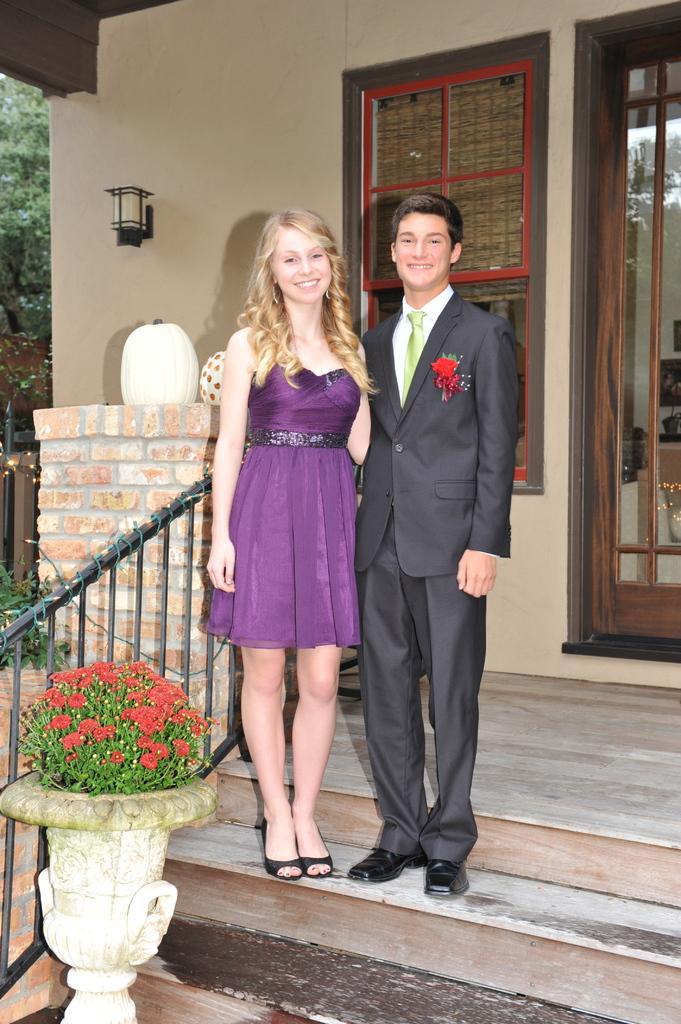How would you summarize this image in a sentence or two? In this image there are two persons standing on the stairs, there is a plant, there are flowers, there is a flower pot truncated towards the bottom of the image, there is a door truncated towards the right of the image, there is a window, there is a wall truncated towards the top of the image, there is light on the wall, there is a tree truncated towards the left of the image. 